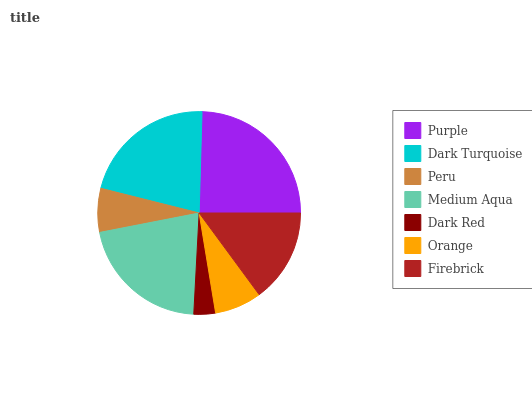Is Dark Red the minimum?
Answer yes or no. Yes. Is Purple the maximum?
Answer yes or no. Yes. Is Dark Turquoise the minimum?
Answer yes or no. No. Is Dark Turquoise the maximum?
Answer yes or no. No. Is Purple greater than Dark Turquoise?
Answer yes or no. Yes. Is Dark Turquoise less than Purple?
Answer yes or no. Yes. Is Dark Turquoise greater than Purple?
Answer yes or no. No. Is Purple less than Dark Turquoise?
Answer yes or no. No. Is Firebrick the high median?
Answer yes or no. Yes. Is Firebrick the low median?
Answer yes or no. Yes. Is Peru the high median?
Answer yes or no. No. Is Medium Aqua the low median?
Answer yes or no. No. 